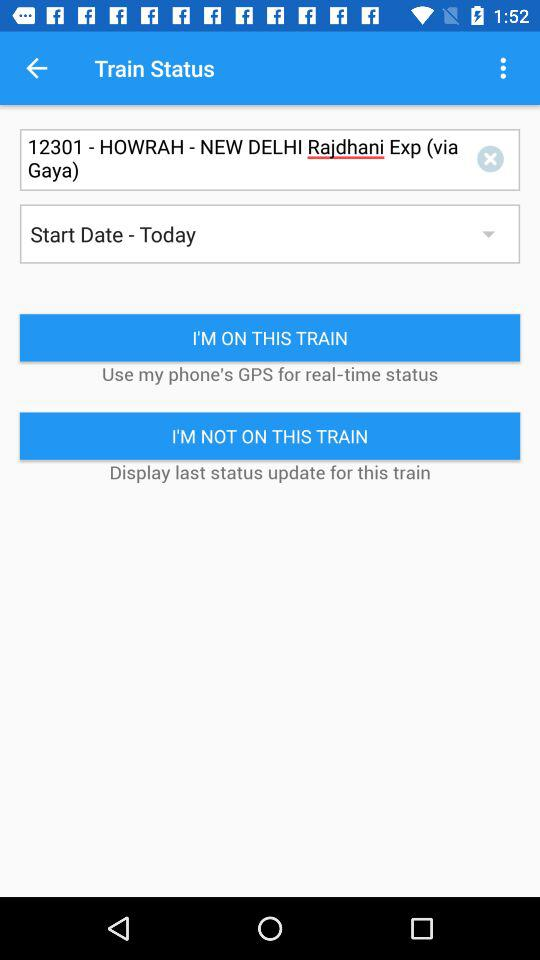What is the name of the train? The name of the train is "HOWRAH - NEW DELHI Rajdhani Exp ". 